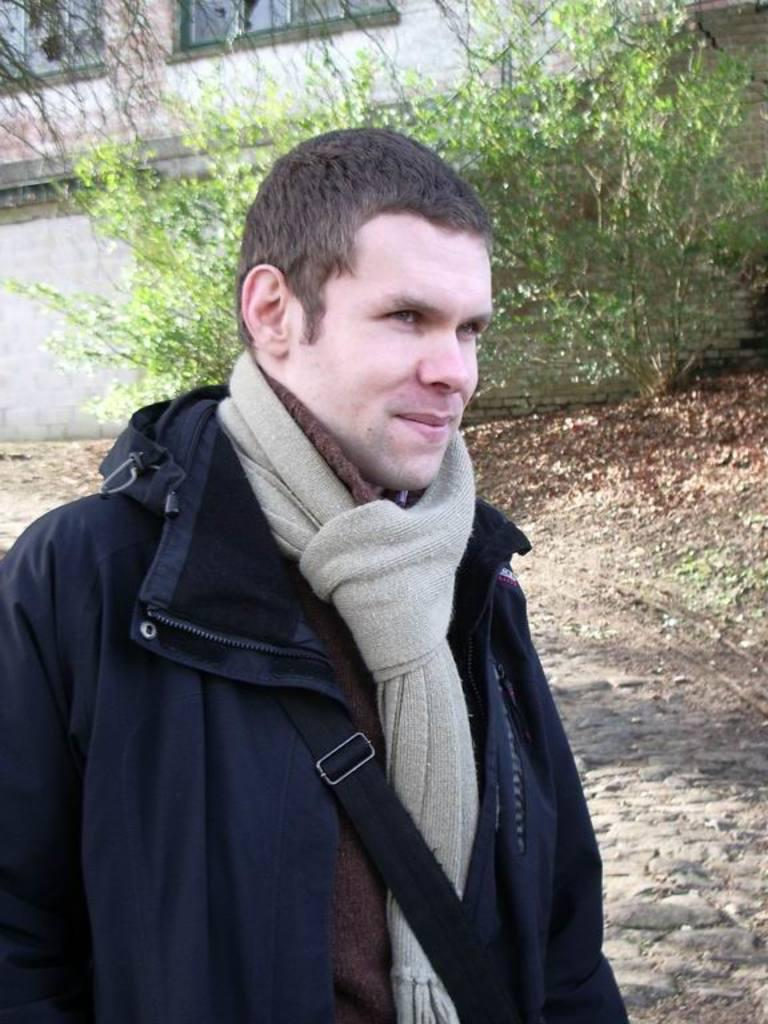Who or what is present in the image? There is a person in the image. What type of structure is visible in the image? There is a wall of a building in the image. What can be seen growing in the image? There are plants in the image. Where are the windows located in the image? There are windows visible in the top left of the image. What type of volleyball is being played by the person in the image? There is no volleyball present in the image, and the person is not playing any sport. 